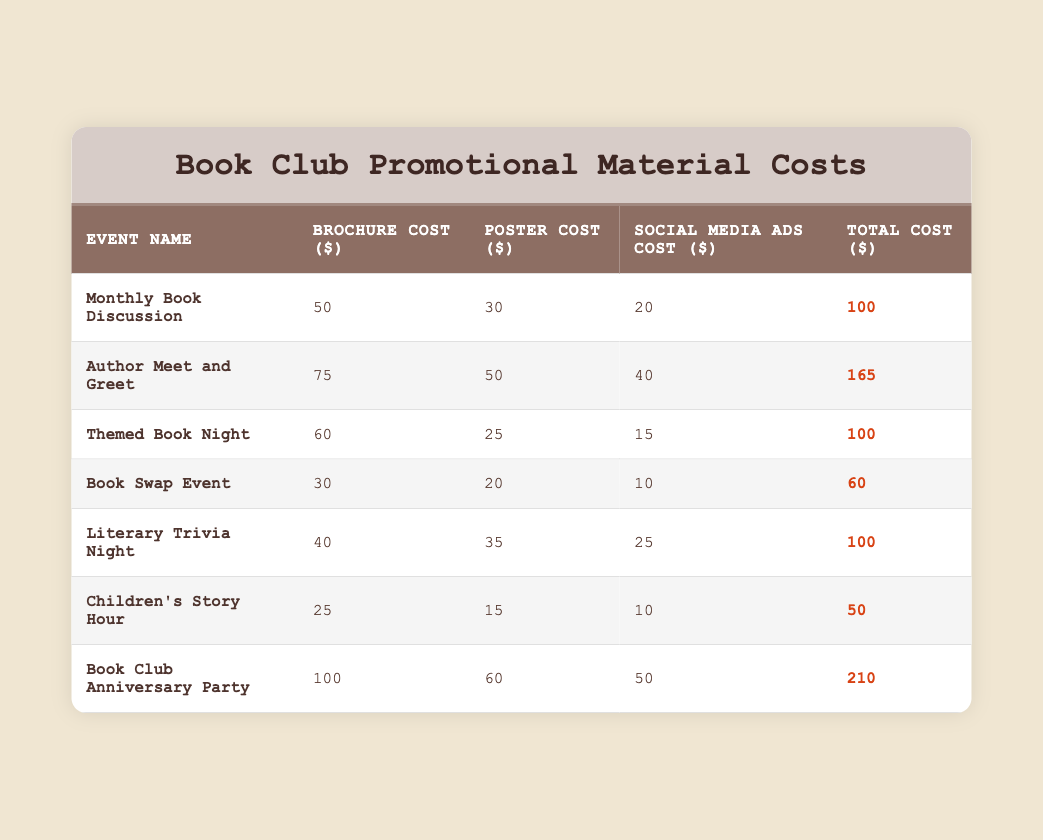What is the total cost of the "Book Swap Event"? According to the table, the total cost for the "Book Swap Event" is listed as 60.
Answer: 60 Which event has the highest promotional material cost? The table shows that the "Book Club Anniversary Party" has the highest total cost of 210.
Answer: 210 What is the total cost for social media ads across all events? To find the total cost for social media ads, I add each social media ads cost: 20 + 40 + 15 + 10 + 25 + 10 + 50 = 170.
Answer: 170 Is the brochure cost for "Children's Story Hour" less than that of the "Monthly Book Discussion"? The brochure cost for "Children's Story Hour" is 25, while for "Monthly Book Discussion" it is 50, so the statement is true.
Answer: Yes What is the average total cost of all the events listed? First, sum the total costs: 100 + 165 + 100 + 60 + 100 + 50 + 210 = 785. There are 7 events, so average total cost = 785 / 7 = 112.14.
Answer: 112.14 How much more does the "Author Meet and Greet" cost compared to the "Literary Trivia Night"? The difference in total cost is calculated as 165 (Author Meet and Greet) - 100 (Literary Trivia Night) = 65.
Answer: 65 Are there any events that have the same total cost? Yes, both the "Monthly Book Discussion" and "Themed Book Night" both have a total cost of 100.
Answer: Yes What percentage of the total cost for the "Book Club Anniversary Party" is attributed to the brochure? The brochure cost for the "Book Club Anniversary Party" is 100, and the total cost is 210. The percentage is calculated as (100 / 210) * 100 = 47.62%.
Answer: 47.62% If I want to create a budget for three events, what would be the total cost of the "Children's Story Hour," "Book Swap Event," and "Themed Book Night"? The total cost for those events is calculated as 50 (Children's Story Hour) + 60 (Book Swap Event) + 100 (Themed Book Night) = 210.
Answer: 210 Which event has the lowest cost for social media ads? By reviewing the table, the "Book Swap Event" has the lowest social media ads cost at 10.
Answer: 10 